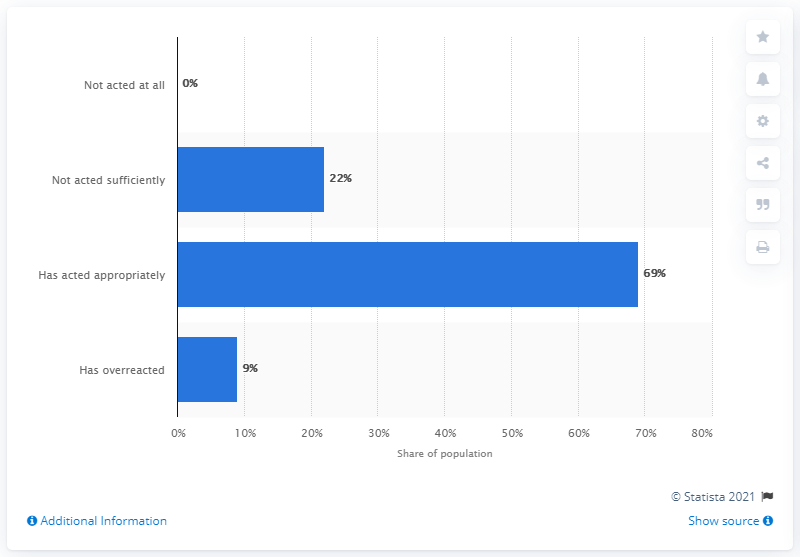List a handful of essential elements in this visual. Approximately 31.884% of the time, the person did not act sufficiently and acted appropriately. The percentage of the big blue bar is 69%. 